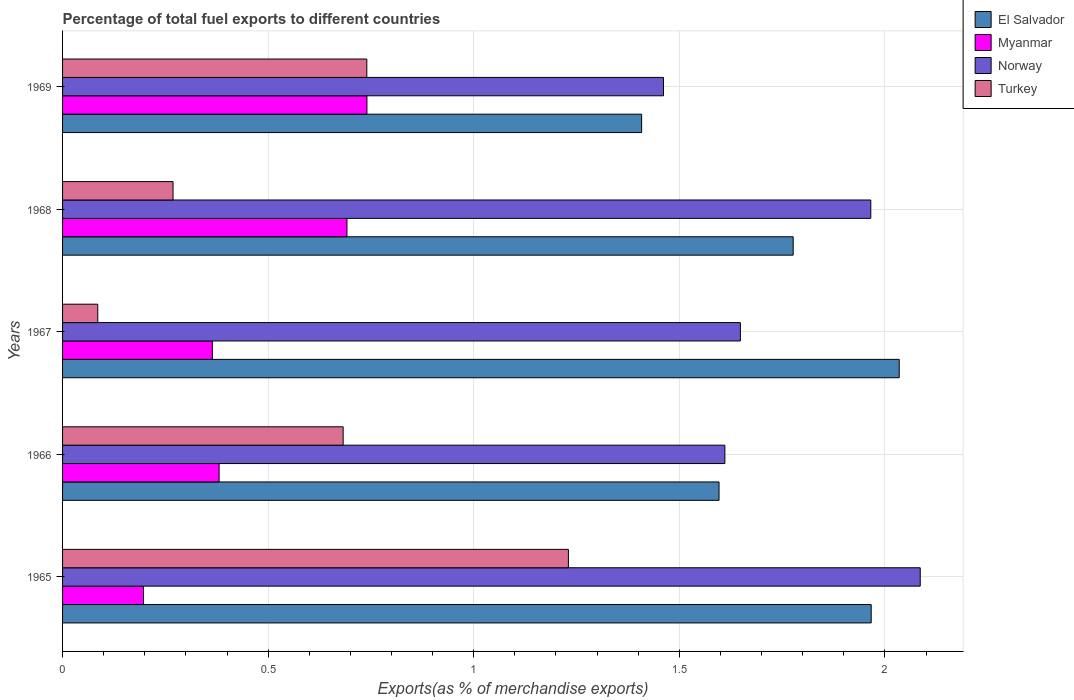Are the number of bars on each tick of the Y-axis equal?
Offer a very short reply. Yes. How many bars are there on the 2nd tick from the top?
Your answer should be very brief. 4. What is the label of the 2nd group of bars from the top?
Your answer should be very brief. 1968. What is the percentage of exports to different countries in Norway in 1967?
Your answer should be very brief. 1.65. Across all years, what is the maximum percentage of exports to different countries in El Salvador?
Provide a short and direct response. 2.03. Across all years, what is the minimum percentage of exports to different countries in Myanmar?
Your answer should be compact. 0.2. In which year was the percentage of exports to different countries in Norway maximum?
Make the answer very short. 1965. In which year was the percentage of exports to different countries in Myanmar minimum?
Give a very brief answer. 1965. What is the total percentage of exports to different countries in Norway in the graph?
Ensure brevity in your answer.  8.77. What is the difference between the percentage of exports to different countries in El Salvador in 1966 and that in 1968?
Ensure brevity in your answer.  -0.18. What is the difference between the percentage of exports to different countries in Norway in 1966 and the percentage of exports to different countries in Myanmar in 1965?
Provide a short and direct response. 1.41. What is the average percentage of exports to different countries in Norway per year?
Ensure brevity in your answer.  1.75. In the year 1966, what is the difference between the percentage of exports to different countries in Myanmar and percentage of exports to different countries in El Salvador?
Your answer should be very brief. -1.22. In how many years, is the percentage of exports to different countries in Turkey greater than 2 %?
Your response must be concise. 0. What is the ratio of the percentage of exports to different countries in El Salvador in 1967 to that in 1968?
Offer a very short reply. 1.15. Is the percentage of exports to different countries in Turkey in 1966 less than that in 1968?
Your answer should be very brief. No. What is the difference between the highest and the second highest percentage of exports to different countries in Myanmar?
Your answer should be compact. 0.05. What is the difference between the highest and the lowest percentage of exports to different countries in El Salvador?
Offer a terse response. 0.63. In how many years, is the percentage of exports to different countries in Norway greater than the average percentage of exports to different countries in Norway taken over all years?
Provide a succinct answer. 2. Is it the case that in every year, the sum of the percentage of exports to different countries in Norway and percentage of exports to different countries in El Salvador is greater than the sum of percentage of exports to different countries in Turkey and percentage of exports to different countries in Myanmar?
Keep it short and to the point. No. What does the 2nd bar from the bottom in 1969 represents?
Provide a succinct answer. Myanmar. How many bars are there?
Your answer should be very brief. 20. Are all the bars in the graph horizontal?
Offer a terse response. Yes. Does the graph contain grids?
Offer a very short reply. Yes. How many legend labels are there?
Provide a short and direct response. 4. How are the legend labels stacked?
Keep it short and to the point. Vertical. What is the title of the graph?
Offer a terse response. Percentage of total fuel exports to different countries. What is the label or title of the X-axis?
Offer a very short reply. Exports(as % of merchandise exports). What is the Exports(as % of merchandise exports) in El Salvador in 1965?
Ensure brevity in your answer.  1.97. What is the Exports(as % of merchandise exports) of Myanmar in 1965?
Your answer should be very brief. 0.2. What is the Exports(as % of merchandise exports) of Norway in 1965?
Offer a very short reply. 2.09. What is the Exports(as % of merchandise exports) of Turkey in 1965?
Offer a very short reply. 1.23. What is the Exports(as % of merchandise exports) of El Salvador in 1966?
Make the answer very short. 1.6. What is the Exports(as % of merchandise exports) in Myanmar in 1966?
Keep it short and to the point. 0.38. What is the Exports(as % of merchandise exports) in Norway in 1966?
Ensure brevity in your answer.  1.61. What is the Exports(as % of merchandise exports) of Turkey in 1966?
Offer a terse response. 0.68. What is the Exports(as % of merchandise exports) of El Salvador in 1967?
Your response must be concise. 2.03. What is the Exports(as % of merchandise exports) in Myanmar in 1967?
Ensure brevity in your answer.  0.36. What is the Exports(as % of merchandise exports) of Norway in 1967?
Make the answer very short. 1.65. What is the Exports(as % of merchandise exports) in Turkey in 1967?
Your answer should be very brief. 0.09. What is the Exports(as % of merchandise exports) in El Salvador in 1968?
Provide a succinct answer. 1.78. What is the Exports(as % of merchandise exports) in Myanmar in 1968?
Your answer should be very brief. 0.69. What is the Exports(as % of merchandise exports) of Norway in 1968?
Give a very brief answer. 1.97. What is the Exports(as % of merchandise exports) in Turkey in 1968?
Ensure brevity in your answer.  0.27. What is the Exports(as % of merchandise exports) in El Salvador in 1969?
Provide a succinct answer. 1.41. What is the Exports(as % of merchandise exports) of Myanmar in 1969?
Offer a very short reply. 0.74. What is the Exports(as % of merchandise exports) of Norway in 1969?
Ensure brevity in your answer.  1.46. What is the Exports(as % of merchandise exports) in Turkey in 1969?
Your answer should be very brief. 0.74. Across all years, what is the maximum Exports(as % of merchandise exports) of El Salvador?
Your response must be concise. 2.03. Across all years, what is the maximum Exports(as % of merchandise exports) in Myanmar?
Your answer should be compact. 0.74. Across all years, what is the maximum Exports(as % of merchandise exports) in Norway?
Keep it short and to the point. 2.09. Across all years, what is the maximum Exports(as % of merchandise exports) of Turkey?
Provide a short and direct response. 1.23. Across all years, what is the minimum Exports(as % of merchandise exports) of El Salvador?
Ensure brevity in your answer.  1.41. Across all years, what is the minimum Exports(as % of merchandise exports) of Myanmar?
Provide a succinct answer. 0.2. Across all years, what is the minimum Exports(as % of merchandise exports) of Norway?
Ensure brevity in your answer.  1.46. Across all years, what is the minimum Exports(as % of merchandise exports) of Turkey?
Provide a succinct answer. 0.09. What is the total Exports(as % of merchandise exports) in El Salvador in the graph?
Offer a very short reply. 8.78. What is the total Exports(as % of merchandise exports) of Myanmar in the graph?
Offer a very short reply. 2.37. What is the total Exports(as % of merchandise exports) of Norway in the graph?
Your answer should be compact. 8.77. What is the total Exports(as % of merchandise exports) of Turkey in the graph?
Ensure brevity in your answer.  3.01. What is the difference between the Exports(as % of merchandise exports) of El Salvador in 1965 and that in 1966?
Keep it short and to the point. 0.37. What is the difference between the Exports(as % of merchandise exports) of Myanmar in 1965 and that in 1966?
Provide a succinct answer. -0.18. What is the difference between the Exports(as % of merchandise exports) of Norway in 1965 and that in 1966?
Provide a succinct answer. 0.48. What is the difference between the Exports(as % of merchandise exports) in Turkey in 1965 and that in 1966?
Offer a terse response. 0.55. What is the difference between the Exports(as % of merchandise exports) of El Salvador in 1965 and that in 1967?
Provide a short and direct response. -0.07. What is the difference between the Exports(as % of merchandise exports) in Myanmar in 1965 and that in 1967?
Provide a short and direct response. -0.17. What is the difference between the Exports(as % of merchandise exports) in Norway in 1965 and that in 1967?
Make the answer very short. 0.44. What is the difference between the Exports(as % of merchandise exports) in Turkey in 1965 and that in 1967?
Provide a short and direct response. 1.14. What is the difference between the Exports(as % of merchandise exports) of El Salvador in 1965 and that in 1968?
Your answer should be very brief. 0.19. What is the difference between the Exports(as % of merchandise exports) in Myanmar in 1965 and that in 1968?
Your answer should be very brief. -0.49. What is the difference between the Exports(as % of merchandise exports) in Norway in 1965 and that in 1968?
Your response must be concise. 0.12. What is the difference between the Exports(as % of merchandise exports) in Turkey in 1965 and that in 1968?
Your response must be concise. 0.96. What is the difference between the Exports(as % of merchandise exports) in El Salvador in 1965 and that in 1969?
Give a very brief answer. 0.56. What is the difference between the Exports(as % of merchandise exports) of Myanmar in 1965 and that in 1969?
Provide a short and direct response. -0.54. What is the difference between the Exports(as % of merchandise exports) of Norway in 1965 and that in 1969?
Make the answer very short. 0.62. What is the difference between the Exports(as % of merchandise exports) in Turkey in 1965 and that in 1969?
Provide a short and direct response. 0.49. What is the difference between the Exports(as % of merchandise exports) of El Salvador in 1966 and that in 1967?
Provide a short and direct response. -0.44. What is the difference between the Exports(as % of merchandise exports) of Myanmar in 1966 and that in 1967?
Provide a succinct answer. 0.02. What is the difference between the Exports(as % of merchandise exports) in Norway in 1966 and that in 1967?
Ensure brevity in your answer.  -0.04. What is the difference between the Exports(as % of merchandise exports) in Turkey in 1966 and that in 1967?
Your response must be concise. 0.6. What is the difference between the Exports(as % of merchandise exports) of El Salvador in 1966 and that in 1968?
Provide a succinct answer. -0.18. What is the difference between the Exports(as % of merchandise exports) of Myanmar in 1966 and that in 1968?
Your answer should be very brief. -0.31. What is the difference between the Exports(as % of merchandise exports) in Norway in 1966 and that in 1968?
Ensure brevity in your answer.  -0.35. What is the difference between the Exports(as % of merchandise exports) of Turkey in 1966 and that in 1968?
Your response must be concise. 0.41. What is the difference between the Exports(as % of merchandise exports) of El Salvador in 1966 and that in 1969?
Your answer should be compact. 0.19. What is the difference between the Exports(as % of merchandise exports) of Myanmar in 1966 and that in 1969?
Your answer should be very brief. -0.36. What is the difference between the Exports(as % of merchandise exports) of Norway in 1966 and that in 1969?
Your response must be concise. 0.15. What is the difference between the Exports(as % of merchandise exports) in Turkey in 1966 and that in 1969?
Provide a succinct answer. -0.06. What is the difference between the Exports(as % of merchandise exports) in El Salvador in 1967 and that in 1968?
Make the answer very short. 0.26. What is the difference between the Exports(as % of merchandise exports) of Myanmar in 1967 and that in 1968?
Offer a terse response. -0.33. What is the difference between the Exports(as % of merchandise exports) in Norway in 1967 and that in 1968?
Your response must be concise. -0.32. What is the difference between the Exports(as % of merchandise exports) of Turkey in 1967 and that in 1968?
Your response must be concise. -0.18. What is the difference between the Exports(as % of merchandise exports) of El Salvador in 1967 and that in 1969?
Provide a short and direct response. 0.63. What is the difference between the Exports(as % of merchandise exports) of Myanmar in 1967 and that in 1969?
Provide a short and direct response. -0.38. What is the difference between the Exports(as % of merchandise exports) of Norway in 1967 and that in 1969?
Your answer should be compact. 0.19. What is the difference between the Exports(as % of merchandise exports) of Turkey in 1967 and that in 1969?
Keep it short and to the point. -0.65. What is the difference between the Exports(as % of merchandise exports) of El Salvador in 1968 and that in 1969?
Make the answer very short. 0.37. What is the difference between the Exports(as % of merchandise exports) in Myanmar in 1968 and that in 1969?
Provide a succinct answer. -0.05. What is the difference between the Exports(as % of merchandise exports) in Norway in 1968 and that in 1969?
Your answer should be compact. 0.5. What is the difference between the Exports(as % of merchandise exports) of Turkey in 1968 and that in 1969?
Give a very brief answer. -0.47. What is the difference between the Exports(as % of merchandise exports) in El Salvador in 1965 and the Exports(as % of merchandise exports) in Myanmar in 1966?
Make the answer very short. 1.59. What is the difference between the Exports(as % of merchandise exports) of El Salvador in 1965 and the Exports(as % of merchandise exports) of Norway in 1966?
Make the answer very short. 0.36. What is the difference between the Exports(as % of merchandise exports) of El Salvador in 1965 and the Exports(as % of merchandise exports) of Turkey in 1966?
Give a very brief answer. 1.28. What is the difference between the Exports(as % of merchandise exports) in Myanmar in 1965 and the Exports(as % of merchandise exports) in Norway in 1966?
Keep it short and to the point. -1.41. What is the difference between the Exports(as % of merchandise exports) of Myanmar in 1965 and the Exports(as % of merchandise exports) of Turkey in 1966?
Your response must be concise. -0.49. What is the difference between the Exports(as % of merchandise exports) of Norway in 1965 and the Exports(as % of merchandise exports) of Turkey in 1966?
Give a very brief answer. 1.4. What is the difference between the Exports(as % of merchandise exports) of El Salvador in 1965 and the Exports(as % of merchandise exports) of Myanmar in 1967?
Offer a very short reply. 1.6. What is the difference between the Exports(as % of merchandise exports) in El Salvador in 1965 and the Exports(as % of merchandise exports) in Norway in 1967?
Your response must be concise. 0.32. What is the difference between the Exports(as % of merchandise exports) of El Salvador in 1965 and the Exports(as % of merchandise exports) of Turkey in 1967?
Give a very brief answer. 1.88. What is the difference between the Exports(as % of merchandise exports) of Myanmar in 1965 and the Exports(as % of merchandise exports) of Norway in 1967?
Provide a short and direct response. -1.45. What is the difference between the Exports(as % of merchandise exports) of Myanmar in 1965 and the Exports(as % of merchandise exports) of Turkey in 1967?
Your answer should be very brief. 0.11. What is the difference between the Exports(as % of merchandise exports) in Norway in 1965 and the Exports(as % of merchandise exports) in Turkey in 1967?
Make the answer very short. 2. What is the difference between the Exports(as % of merchandise exports) of El Salvador in 1965 and the Exports(as % of merchandise exports) of Myanmar in 1968?
Ensure brevity in your answer.  1.27. What is the difference between the Exports(as % of merchandise exports) of El Salvador in 1965 and the Exports(as % of merchandise exports) of Turkey in 1968?
Offer a very short reply. 1.7. What is the difference between the Exports(as % of merchandise exports) of Myanmar in 1965 and the Exports(as % of merchandise exports) of Norway in 1968?
Provide a succinct answer. -1.77. What is the difference between the Exports(as % of merchandise exports) in Myanmar in 1965 and the Exports(as % of merchandise exports) in Turkey in 1968?
Your answer should be very brief. -0.07. What is the difference between the Exports(as % of merchandise exports) in Norway in 1965 and the Exports(as % of merchandise exports) in Turkey in 1968?
Ensure brevity in your answer.  1.82. What is the difference between the Exports(as % of merchandise exports) of El Salvador in 1965 and the Exports(as % of merchandise exports) of Myanmar in 1969?
Keep it short and to the point. 1.23. What is the difference between the Exports(as % of merchandise exports) of El Salvador in 1965 and the Exports(as % of merchandise exports) of Norway in 1969?
Ensure brevity in your answer.  0.51. What is the difference between the Exports(as % of merchandise exports) of El Salvador in 1965 and the Exports(as % of merchandise exports) of Turkey in 1969?
Provide a succinct answer. 1.23. What is the difference between the Exports(as % of merchandise exports) in Myanmar in 1965 and the Exports(as % of merchandise exports) in Norway in 1969?
Your answer should be compact. -1.26. What is the difference between the Exports(as % of merchandise exports) in Myanmar in 1965 and the Exports(as % of merchandise exports) in Turkey in 1969?
Offer a terse response. -0.54. What is the difference between the Exports(as % of merchandise exports) of Norway in 1965 and the Exports(as % of merchandise exports) of Turkey in 1969?
Offer a terse response. 1.35. What is the difference between the Exports(as % of merchandise exports) of El Salvador in 1966 and the Exports(as % of merchandise exports) of Myanmar in 1967?
Offer a terse response. 1.23. What is the difference between the Exports(as % of merchandise exports) of El Salvador in 1966 and the Exports(as % of merchandise exports) of Norway in 1967?
Offer a very short reply. -0.05. What is the difference between the Exports(as % of merchandise exports) in El Salvador in 1966 and the Exports(as % of merchandise exports) in Turkey in 1967?
Provide a succinct answer. 1.51. What is the difference between the Exports(as % of merchandise exports) in Myanmar in 1966 and the Exports(as % of merchandise exports) in Norway in 1967?
Your answer should be very brief. -1.27. What is the difference between the Exports(as % of merchandise exports) of Myanmar in 1966 and the Exports(as % of merchandise exports) of Turkey in 1967?
Provide a succinct answer. 0.3. What is the difference between the Exports(as % of merchandise exports) in Norway in 1966 and the Exports(as % of merchandise exports) in Turkey in 1967?
Offer a terse response. 1.53. What is the difference between the Exports(as % of merchandise exports) in El Salvador in 1966 and the Exports(as % of merchandise exports) in Myanmar in 1968?
Offer a terse response. 0.9. What is the difference between the Exports(as % of merchandise exports) in El Salvador in 1966 and the Exports(as % of merchandise exports) in Norway in 1968?
Keep it short and to the point. -0.37. What is the difference between the Exports(as % of merchandise exports) of El Salvador in 1966 and the Exports(as % of merchandise exports) of Turkey in 1968?
Make the answer very short. 1.33. What is the difference between the Exports(as % of merchandise exports) in Myanmar in 1966 and the Exports(as % of merchandise exports) in Norway in 1968?
Provide a succinct answer. -1.58. What is the difference between the Exports(as % of merchandise exports) of Myanmar in 1966 and the Exports(as % of merchandise exports) of Turkey in 1968?
Offer a very short reply. 0.11. What is the difference between the Exports(as % of merchandise exports) in Norway in 1966 and the Exports(as % of merchandise exports) in Turkey in 1968?
Make the answer very short. 1.34. What is the difference between the Exports(as % of merchandise exports) of El Salvador in 1966 and the Exports(as % of merchandise exports) of Myanmar in 1969?
Your response must be concise. 0.86. What is the difference between the Exports(as % of merchandise exports) in El Salvador in 1966 and the Exports(as % of merchandise exports) in Norway in 1969?
Offer a very short reply. 0.14. What is the difference between the Exports(as % of merchandise exports) of El Salvador in 1966 and the Exports(as % of merchandise exports) of Turkey in 1969?
Keep it short and to the point. 0.86. What is the difference between the Exports(as % of merchandise exports) of Myanmar in 1966 and the Exports(as % of merchandise exports) of Norway in 1969?
Offer a very short reply. -1.08. What is the difference between the Exports(as % of merchandise exports) of Myanmar in 1966 and the Exports(as % of merchandise exports) of Turkey in 1969?
Provide a short and direct response. -0.36. What is the difference between the Exports(as % of merchandise exports) of Norway in 1966 and the Exports(as % of merchandise exports) of Turkey in 1969?
Your answer should be very brief. 0.87. What is the difference between the Exports(as % of merchandise exports) of El Salvador in 1967 and the Exports(as % of merchandise exports) of Myanmar in 1968?
Offer a very short reply. 1.34. What is the difference between the Exports(as % of merchandise exports) in El Salvador in 1967 and the Exports(as % of merchandise exports) in Norway in 1968?
Your answer should be compact. 0.07. What is the difference between the Exports(as % of merchandise exports) of El Salvador in 1967 and the Exports(as % of merchandise exports) of Turkey in 1968?
Give a very brief answer. 1.77. What is the difference between the Exports(as % of merchandise exports) in Myanmar in 1967 and the Exports(as % of merchandise exports) in Norway in 1968?
Your answer should be compact. -1.6. What is the difference between the Exports(as % of merchandise exports) in Myanmar in 1967 and the Exports(as % of merchandise exports) in Turkey in 1968?
Your answer should be compact. 0.1. What is the difference between the Exports(as % of merchandise exports) of Norway in 1967 and the Exports(as % of merchandise exports) of Turkey in 1968?
Provide a short and direct response. 1.38. What is the difference between the Exports(as % of merchandise exports) of El Salvador in 1967 and the Exports(as % of merchandise exports) of Myanmar in 1969?
Ensure brevity in your answer.  1.29. What is the difference between the Exports(as % of merchandise exports) of El Salvador in 1967 and the Exports(as % of merchandise exports) of Norway in 1969?
Offer a terse response. 0.57. What is the difference between the Exports(as % of merchandise exports) in El Salvador in 1967 and the Exports(as % of merchandise exports) in Turkey in 1969?
Your answer should be compact. 1.29. What is the difference between the Exports(as % of merchandise exports) of Myanmar in 1967 and the Exports(as % of merchandise exports) of Norway in 1969?
Offer a very short reply. -1.1. What is the difference between the Exports(as % of merchandise exports) of Myanmar in 1967 and the Exports(as % of merchandise exports) of Turkey in 1969?
Offer a very short reply. -0.38. What is the difference between the Exports(as % of merchandise exports) in Norway in 1967 and the Exports(as % of merchandise exports) in Turkey in 1969?
Your response must be concise. 0.91. What is the difference between the Exports(as % of merchandise exports) of El Salvador in 1968 and the Exports(as % of merchandise exports) of Myanmar in 1969?
Your answer should be very brief. 1.04. What is the difference between the Exports(as % of merchandise exports) of El Salvador in 1968 and the Exports(as % of merchandise exports) of Norway in 1969?
Your answer should be compact. 0.32. What is the difference between the Exports(as % of merchandise exports) of Myanmar in 1968 and the Exports(as % of merchandise exports) of Norway in 1969?
Your answer should be very brief. -0.77. What is the difference between the Exports(as % of merchandise exports) of Myanmar in 1968 and the Exports(as % of merchandise exports) of Turkey in 1969?
Ensure brevity in your answer.  -0.05. What is the difference between the Exports(as % of merchandise exports) of Norway in 1968 and the Exports(as % of merchandise exports) of Turkey in 1969?
Your response must be concise. 1.23. What is the average Exports(as % of merchandise exports) of El Salvador per year?
Your answer should be compact. 1.76. What is the average Exports(as % of merchandise exports) in Myanmar per year?
Give a very brief answer. 0.47. What is the average Exports(as % of merchandise exports) in Norway per year?
Ensure brevity in your answer.  1.75. What is the average Exports(as % of merchandise exports) of Turkey per year?
Your answer should be compact. 0.6. In the year 1965, what is the difference between the Exports(as % of merchandise exports) of El Salvador and Exports(as % of merchandise exports) of Myanmar?
Offer a terse response. 1.77. In the year 1965, what is the difference between the Exports(as % of merchandise exports) of El Salvador and Exports(as % of merchandise exports) of Norway?
Your answer should be very brief. -0.12. In the year 1965, what is the difference between the Exports(as % of merchandise exports) in El Salvador and Exports(as % of merchandise exports) in Turkey?
Your response must be concise. 0.74. In the year 1965, what is the difference between the Exports(as % of merchandise exports) in Myanmar and Exports(as % of merchandise exports) in Norway?
Keep it short and to the point. -1.89. In the year 1965, what is the difference between the Exports(as % of merchandise exports) in Myanmar and Exports(as % of merchandise exports) in Turkey?
Keep it short and to the point. -1.03. In the year 1965, what is the difference between the Exports(as % of merchandise exports) in Norway and Exports(as % of merchandise exports) in Turkey?
Your response must be concise. 0.86. In the year 1966, what is the difference between the Exports(as % of merchandise exports) in El Salvador and Exports(as % of merchandise exports) in Myanmar?
Your answer should be compact. 1.22. In the year 1966, what is the difference between the Exports(as % of merchandise exports) in El Salvador and Exports(as % of merchandise exports) in Norway?
Offer a very short reply. -0.01. In the year 1966, what is the difference between the Exports(as % of merchandise exports) in El Salvador and Exports(as % of merchandise exports) in Turkey?
Offer a very short reply. 0.91. In the year 1966, what is the difference between the Exports(as % of merchandise exports) of Myanmar and Exports(as % of merchandise exports) of Norway?
Provide a succinct answer. -1.23. In the year 1966, what is the difference between the Exports(as % of merchandise exports) of Myanmar and Exports(as % of merchandise exports) of Turkey?
Offer a terse response. -0.3. In the year 1966, what is the difference between the Exports(as % of merchandise exports) of Norway and Exports(as % of merchandise exports) of Turkey?
Give a very brief answer. 0.93. In the year 1967, what is the difference between the Exports(as % of merchandise exports) in El Salvador and Exports(as % of merchandise exports) in Myanmar?
Offer a terse response. 1.67. In the year 1967, what is the difference between the Exports(as % of merchandise exports) in El Salvador and Exports(as % of merchandise exports) in Norway?
Offer a very short reply. 0.39. In the year 1967, what is the difference between the Exports(as % of merchandise exports) of El Salvador and Exports(as % of merchandise exports) of Turkey?
Your answer should be very brief. 1.95. In the year 1967, what is the difference between the Exports(as % of merchandise exports) in Myanmar and Exports(as % of merchandise exports) in Norway?
Make the answer very short. -1.28. In the year 1967, what is the difference between the Exports(as % of merchandise exports) in Myanmar and Exports(as % of merchandise exports) in Turkey?
Ensure brevity in your answer.  0.28. In the year 1967, what is the difference between the Exports(as % of merchandise exports) in Norway and Exports(as % of merchandise exports) in Turkey?
Provide a succinct answer. 1.56. In the year 1968, what is the difference between the Exports(as % of merchandise exports) in El Salvador and Exports(as % of merchandise exports) in Myanmar?
Your answer should be compact. 1.09. In the year 1968, what is the difference between the Exports(as % of merchandise exports) in El Salvador and Exports(as % of merchandise exports) in Norway?
Your answer should be very brief. -0.19. In the year 1968, what is the difference between the Exports(as % of merchandise exports) of El Salvador and Exports(as % of merchandise exports) of Turkey?
Your answer should be very brief. 1.51. In the year 1968, what is the difference between the Exports(as % of merchandise exports) of Myanmar and Exports(as % of merchandise exports) of Norway?
Your answer should be compact. -1.27. In the year 1968, what is the difference between the Exports(as % of merchandise exports) in Myanmar and Exports(as % of merchandise exports) in Turkey?
Keep it short and to the point. 0.42. In the year 1968, what is the difference between the Exports(as % of merchandise exports) of Norway and Exports(as % of merchandise exports) of Turkey?
Offer a terse response. 1.7. In the year 1969, what is the difference between the Exports(as % of merchandise exports) in El Salvador and Exports(as % of merchandise exports) in Myanmar?
Offer a very short reply. 0.67. In the year 1969, what is the difference between the Exports(as % of merchandise exports) of El Salvador and Exports(as % of merchandise exports) of Norway?
Keep it short and to the point. -0.05. In the year 1969, what is the difference between the Exports(as % of merchandise exports) of El Salvador and Exports(as % of merchandise exports) of Turkey?
Make the answer very short. 0.67. In the year 1969, what is the difference between the Exports(as % of merchandise exports) in Myanmar and Exports(as % of merchandise exports) in Norway?
Your response must be concise. -0.72. In the year 1969, what is the difference between the Exports(as % of merchandise exports) of Myanmar and Exports(as % of merchandise exports) of Turkey?
Ensure brevity in your answer.  0. In the year 1969, what is the difference between the Exports(as % of merchandise exports) of Norway and Exports(as % of merchandise exports) of Turkey?
Provide a short and direct response. 0.72. What is the ratio of the Exports(as % of merchandise exports) of El Salvador in 1965 to that in 1966?
Your response must be concise. 1.23. What is the ratio of the Exports(as % of merchandise exports) of Myanmar in 1965 to that in 1966?
Ensure brevity in your answer.  0.52. What is the ratio of the Exports(as % of merchandise exports) of Norway in 1965 to that in 1966?
Offer a terse response. 1.29. What is the ratio of the Exports(as % of merchandise exports) in Turkey in 1965 to that in 1966?
Offer a terse response. 1.8. What is the ratio of the Exports(as % of merchandise exports) of El Salvador in 1965 to that in 1967?
Your answer should be very brief. 0.97. What is the ratio of the Exports(as % of merchandise exports) in Myanmar in 1965 to that in 1967?
Your answer should be very brief. 0.54. What is the ratio of the Exports(as % of merchandise exports) in Norway in 1965 to that in 1967?
Make the answer very short. 1.27. What is the ratio of the Exports(as % of merchandise exports) of Turkey in 1965 to that in 1967?
Offer a terse response. 14.37. What is the ratio of the Exports(as % of merchandise exports) of El Salvador in 1965 to that in 1968?
Your answer should be compact. 1.11. What is the ratio of the Exports(as % of merchandise exports) of Myanmar in 1965 to that in 1968?
Keep it short and to the point. 0.28. What is the ratio of the Exports(as % of merchandise exports) in Norway in 1965 to that in 1968?
Your answer should be very brief. 1.06. What is the ratio of the Exports(as % of merchandise exports) of Turkey in 1965 to that in 1968?
Provide a succinct answer. 4.58. What is the ratio of the Exports(as % of merchandise exports) in El Salvador in 1965 to that in 1969?
Give a very brief answer. 1.4. What is the ratio of the Exports(as % of merchandise exports) of Myanmar in 1965 to that in 1969?
Keep it short and to the point. 0.27. What is the ratio of the Exports(as % of merchandise exports) in Norway in 1965 to that in 1969?
Your answer should be very brief. 1.43. What is the ratio of the Exports(as % of merchandise exports) of Turkey in 1965 to that in 1969?
Give a very brief answer. 1.66. What is the ratio of the Exports(as % of merchandise exports) in El Salvador in 1966 to that in 1967?
Keep it short and to the point. 0.78. What is the ratio of the Exports(as % of merchandise exports) in Myanmar in 1966 to that in 1967?
Give a very brief answer. 1.05. What is the ratio of the Exports(as % of merchandise exports) of Norway in 1966 to that in 1967?
Make the answer very short. 0.98. What is the ratio of the Exports(as % of merchandise exports) of Turkey in 1966 to that in 1967?
Your answer should be very brief. 7.97. What is the ratio of the Exports(as % of merchandise exports) of El Salvador in 1966 to that in 1968?
Offer a very short reply. 0.9. What is the ratio of the Exports(as % of merchandise exports) in Myanmar in 1966 to that in 1968?
Give a very brief answer. 0.55. What is the ratio of the Exports(as % of merchandise exports) in Norway in 1966 to that in 1968?
Provide a short and direct response. 0.82. What is the ratio of the Exports(as % of merchandise exports) of Turkey in 1966 to that in 1968?
Your answer should be compact. 2.54. What is the ratio of the Exports(as % of merchandise exports) in El Salvador in 1966 to that in 1969?
Your answer should be very brief. 1.13. What is the ratio of the Exports(as % of merchandise exports) of Myanmar in 1966 to that in 1969?
Make the answer very short. 0.51. What is the ratio of the Exports(as % of merchandise exports) in Norway in 1966 to that in 1969?
Provide a short and direct response. 1.1. What is the ratio of the Exports(as % of merchandise exports) of Turkey in 1966 to that in 1969?
Give a very brief answer. 0.92. What is the ratio of the Exports(as % of merchandise exports) in El Salvador in 1967 to that in 1968?
Offer a terse response. 1.15. What is the ratio of the Exports(as % of merchandise exports) in Myanmar in 1967 to that in 1968?
Provide a short and direct response. 0.53. What is the ratio of the Exports(as % of merchandise exports) in Norway in 1967 to that in 1968?
Provide a short and direct response. 0.84. What is the ratio of the Exports(as % of merchandise exports) in Turkey in 1967 to that in 1968?
Your answer should be compact. 0.32. What is the ratio of the Exports(as % of merchandise exports) of El Salvador in 1967 to that in 1969?
Give a very brief answer. 1.44. What is the ratio of the Exports(as % of merchandise exports) of Myanmar in 1967 to that in 1969?
Make the answer very short. 0.49. What is the ratio of the Exports(as % of merchandise exports) of Norway in 1967 to that in 1969?
Provide a succinct answer. 1.13. What is the ratio of the Exports(as % of merchandise exports) of Turkey in 1967 to that in 1969?
Keep it short and to the point. 0.12. What is the ratio of the Exports(as % of merchandise exports) in El Salvador in 1968 to that in 1969?
Provide a short and direct response. 1.26. What is the ratio of the Exports(as % of merchandise exports) of Myanmar in 1968 to that in 1969?
Offer a terse response. 0.93. What is the ratio of the Exports(as % of merchandise exports) of Norway in 1968 to that in 1969?
Provide a succinct answer. 1.34. What is the ratio of the Exports(as % of merchandise exports) in Turkey in 1968 to that in 1969?
Provide a short and direct response. 0.36. What is the difference between the highest and the second highest Exports(as % of merchandise exports) in El Salvador?
Provide a short and direct response. 0.07. What is the difference between the highest and the second highest Exports(as % of merchandise exports) in Myanmar?
Ensure brevity in your answer.  0.05. What is the difference between the highest and the second highest Exports(as % of merchandise exports) in Norway?
Your response must be concise. 0.12. What is the difference between the highest and the second highest Exports(as % of merchandise exports) in Turkey?
Give a very brief answer. 0.49. What is the difference between the highest and the lowest Exports(as % of merchandise exports) of El Salvador?
Provide a short and direct response. 0.63. What is the difference between the highest and the lowest Exports(as % of merchandise exports) in Myanmar?
Make the answer very short. 0.54. What is the difference between the highest and the lowest Exports(as % of merchandise exports) in Norway?
Make the answer very short. 0.62. What is the difference between the highest and the lowest Exports(as % of merchandise exports) of Turkey?
Offer a very short reply. 1.14. 